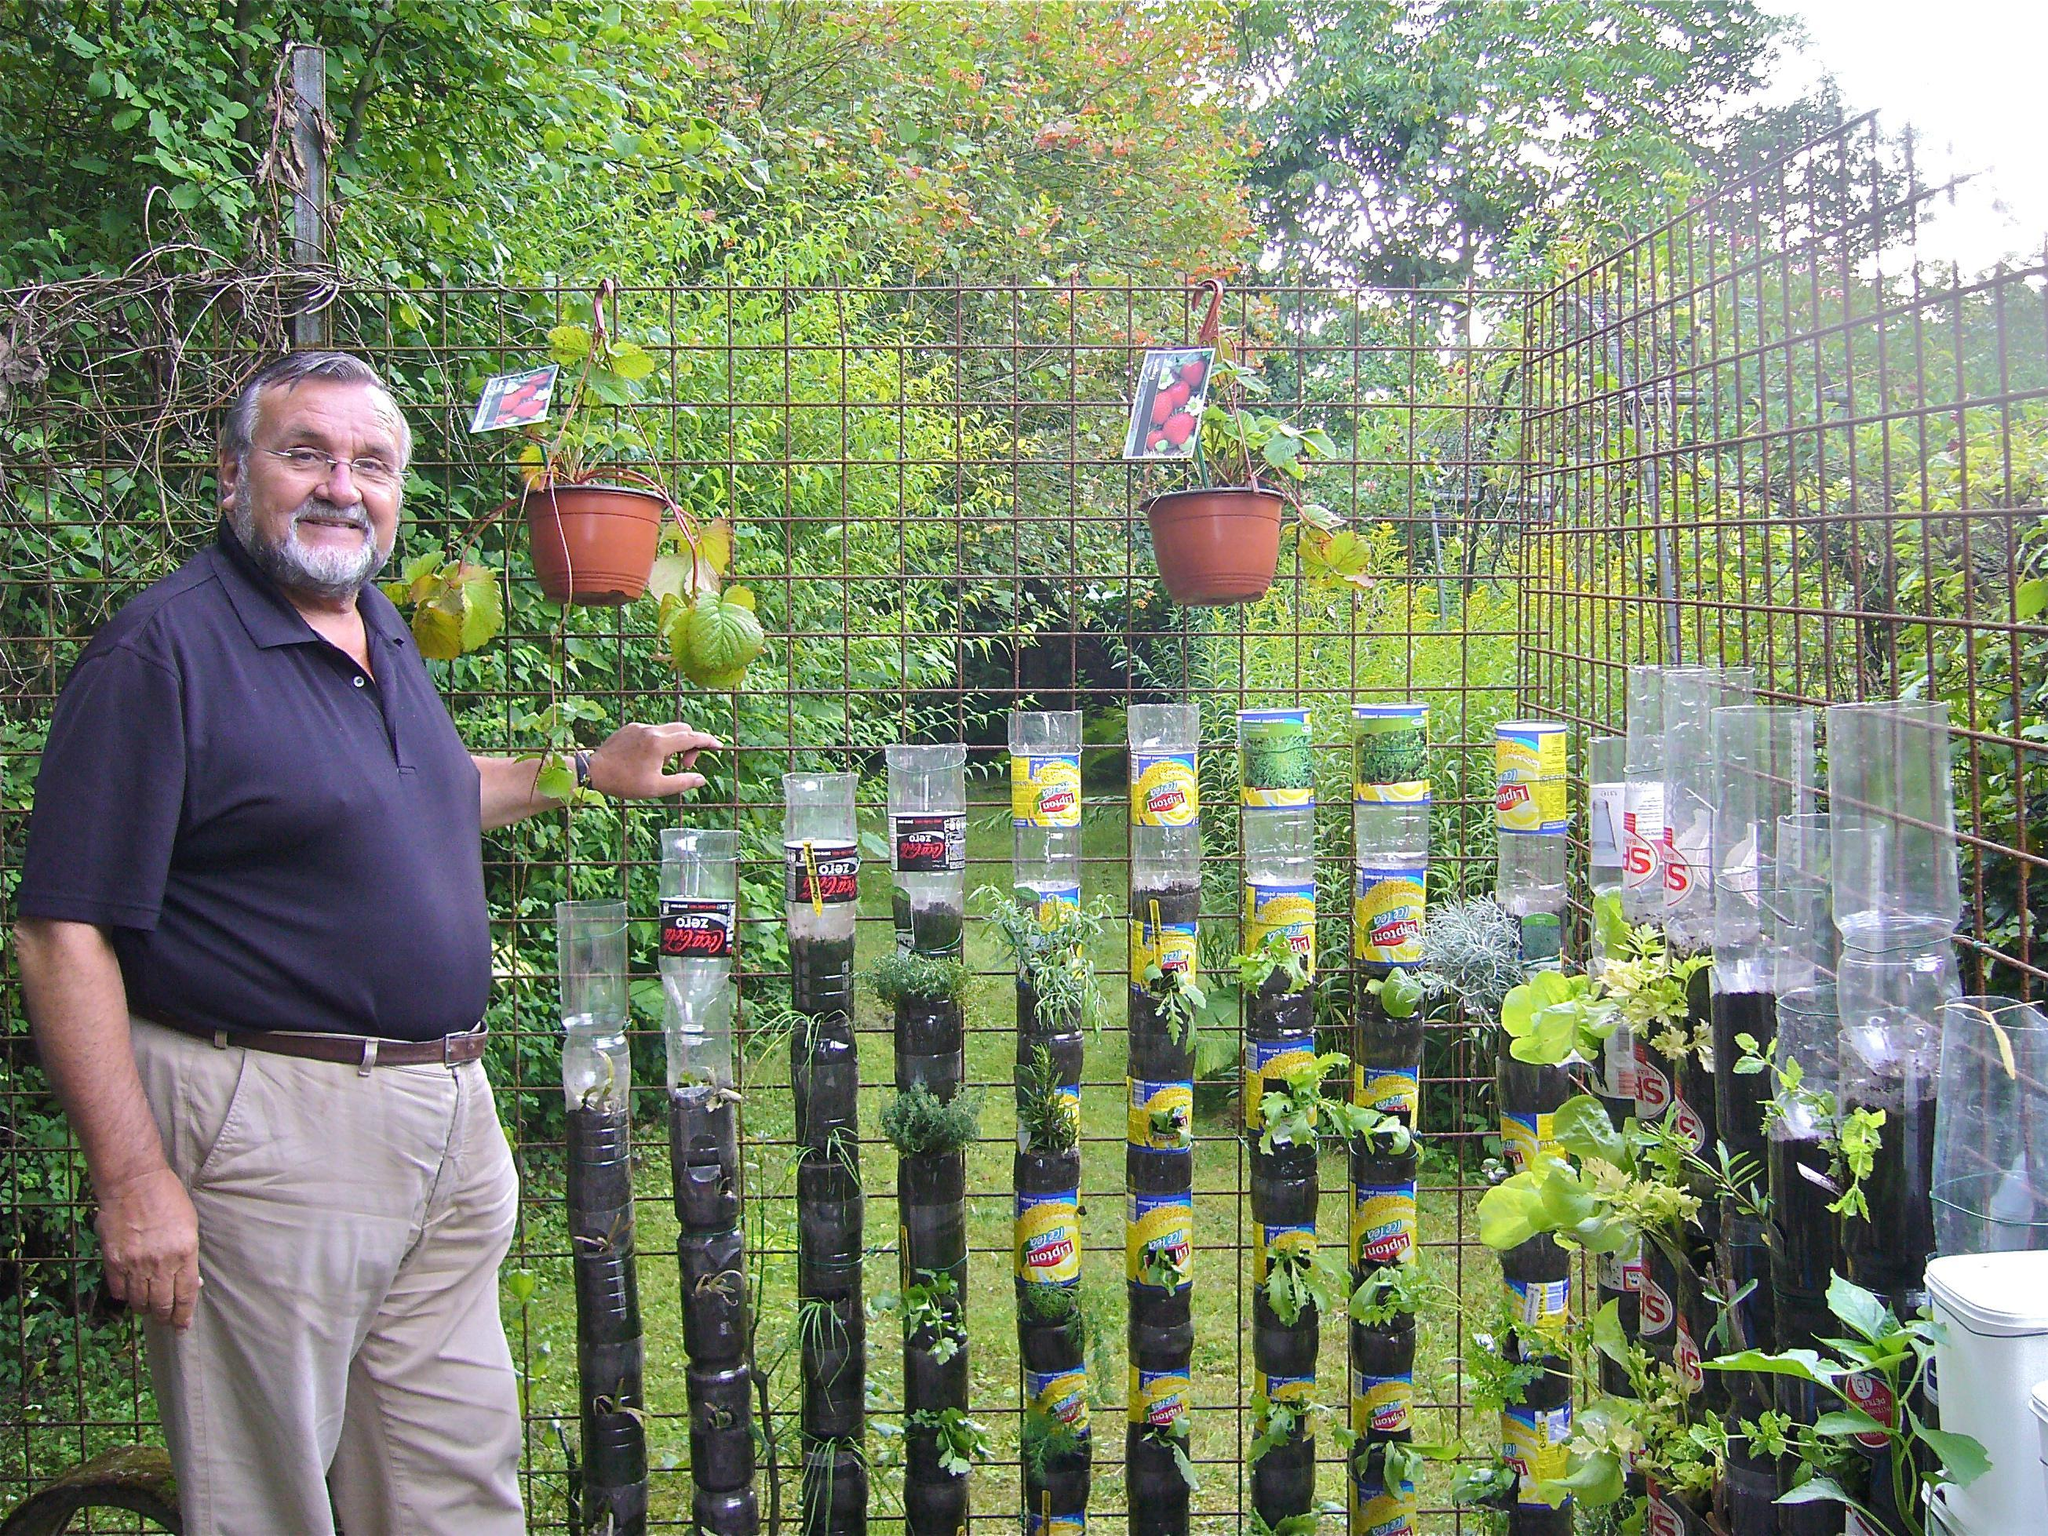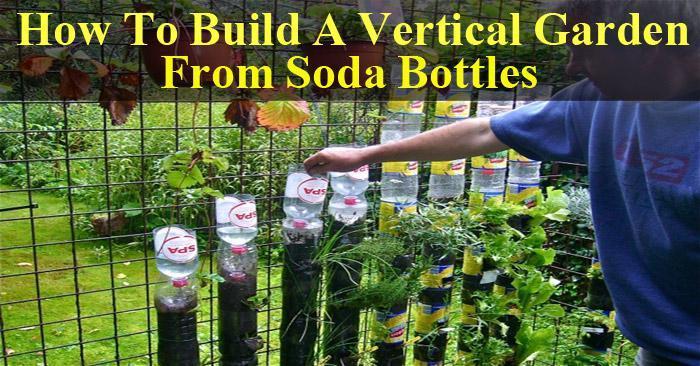The first image is the image on the left, the second image is the image on the right. Examine the images to the left and right. Is the description "A man in a blue shirt is tending to a garden in the image on the right." accurate? Answer yes or no. Yes. The first image is the image on the left, the second image is the image on the right. Analyze the images presented: Is the assertion "One image shows a man in a blue shirt standing in front of two hanging orange planters and a row of cylinder shapes topped with up-ended plastic bottles." valid? Answer yes or no. Yes. 